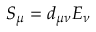Convert formula to latex. <formula><loc_0><loc_0><loc_500><loc_500>S _ { \mu } = d _ { \mu \nu } E _ { \nu }</formula> 